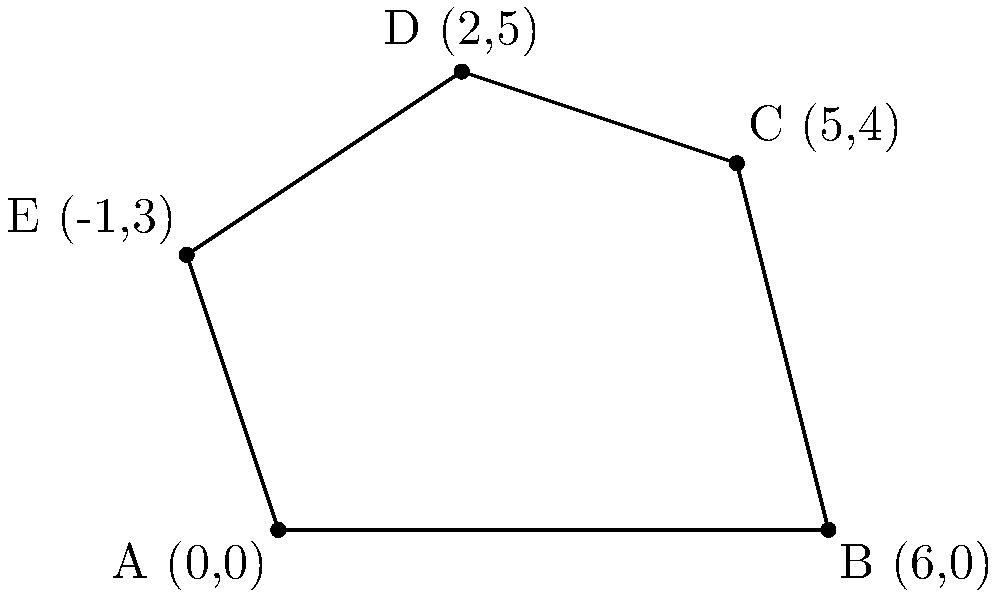In a network security assessment, five access points are identified and plotted on a coordinate system as shown in the diagram. The points represent the physical locations of these access points in a facility. Calculate the area of the irregular polygon formed by connecting these points, which represents the coverage area of the network. The coordinates of the points are A(0,0), B(6,0), C(5,4), D(2,5), and E(-1,3). To find the area of this irregular polygon, we can use the Shoelace formula (also known as the surveyor's formula). The steps are as follows:

1) The Shoelace formula for a polygon with vertices $(x_1, y_1), (x_2, y_2), ..., (x_n, y_n)$ is:

   Area = $\frac{1}{2}|((x_1y_2 + x_2y_3 + ... + x_ny_1) - (y_1x_2 + y_2x_3 + ... + y_nx_1))|$

2) Let's organize our points:
   A(0,0), B(6,0), C(5,4), D(2,5), E(-1,3)

3) Apply the formula:

   Area = $\frac{1}{2}|((0 \cdot 0 + 6 \cdot 4 + 5 \cdot 5 + 2 \cdot 3 + (-1) \cdot 0) - (0 \cdot 6 + 0 \cdot 5 + 4 \cdot 2 + 5 \cdot (-1) + 3 \cdot 0))|$

4) Simplify:
   Area = $\frac{1}{2}|((0 + 24 + 25 + 6 + 0) - (0 + 0 + 8 - 5 + 0))|$
   
   Area = $\frac{1}{2}|(55 - 3)|$
   
   Area = $\frac{1}{2}(52)$
   
   Area = 26

Therefore, the area of the polygon representing the network coverage is 26 square units.
Answer: 26 square units 